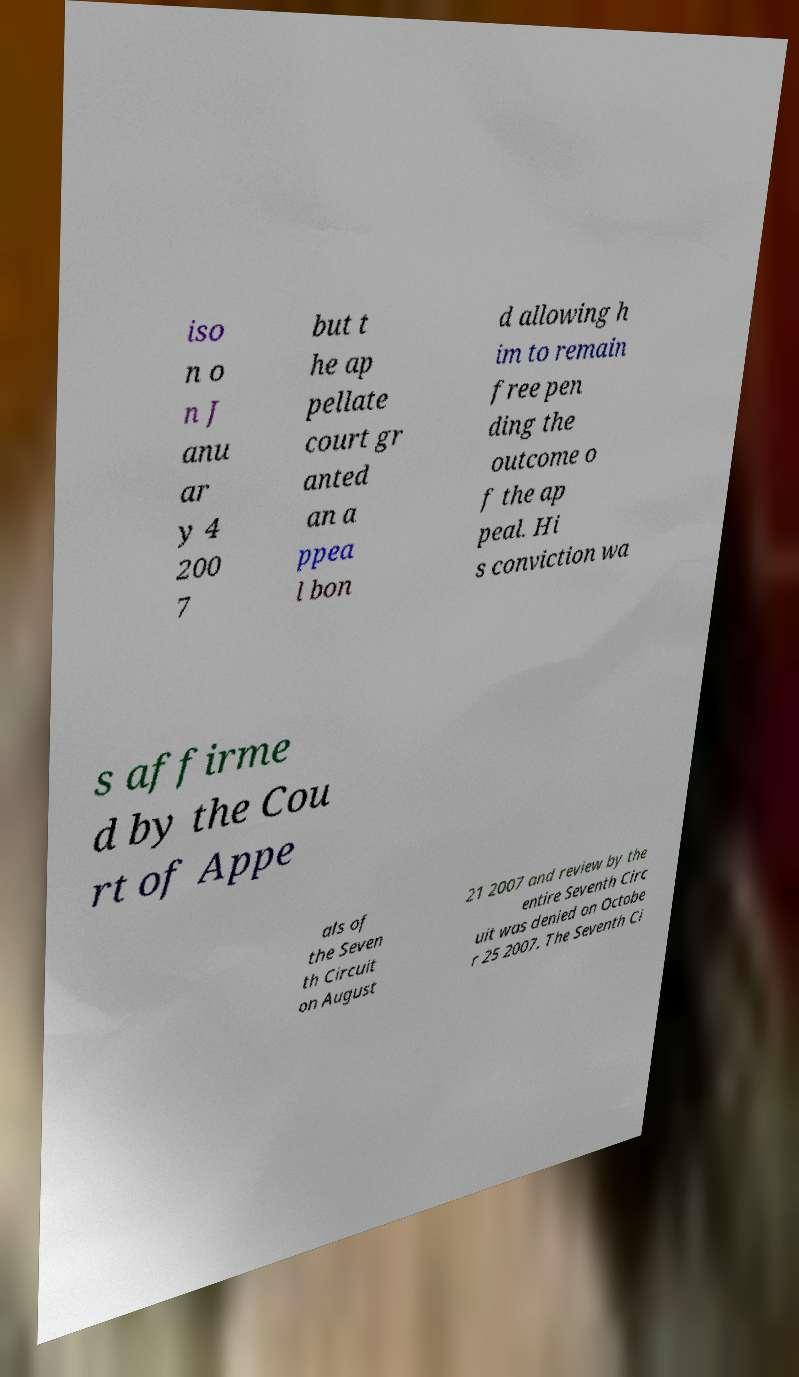Please read and relay the text visible in this image. What does it say? iso n o n J anu ar y 4 200 7 but t he ap pellate court gr anted an a ppea l bon d allowing h im to remain free pen ding the outcome o f the ap peal. Hi s conviction wa s affirme d by the Cou rt of Appe als of the Seven th Circuit on August 21 2007 and review by the entire Seventh Circ uit was denied on Octobe r 25 2007. The Seventh Ci 